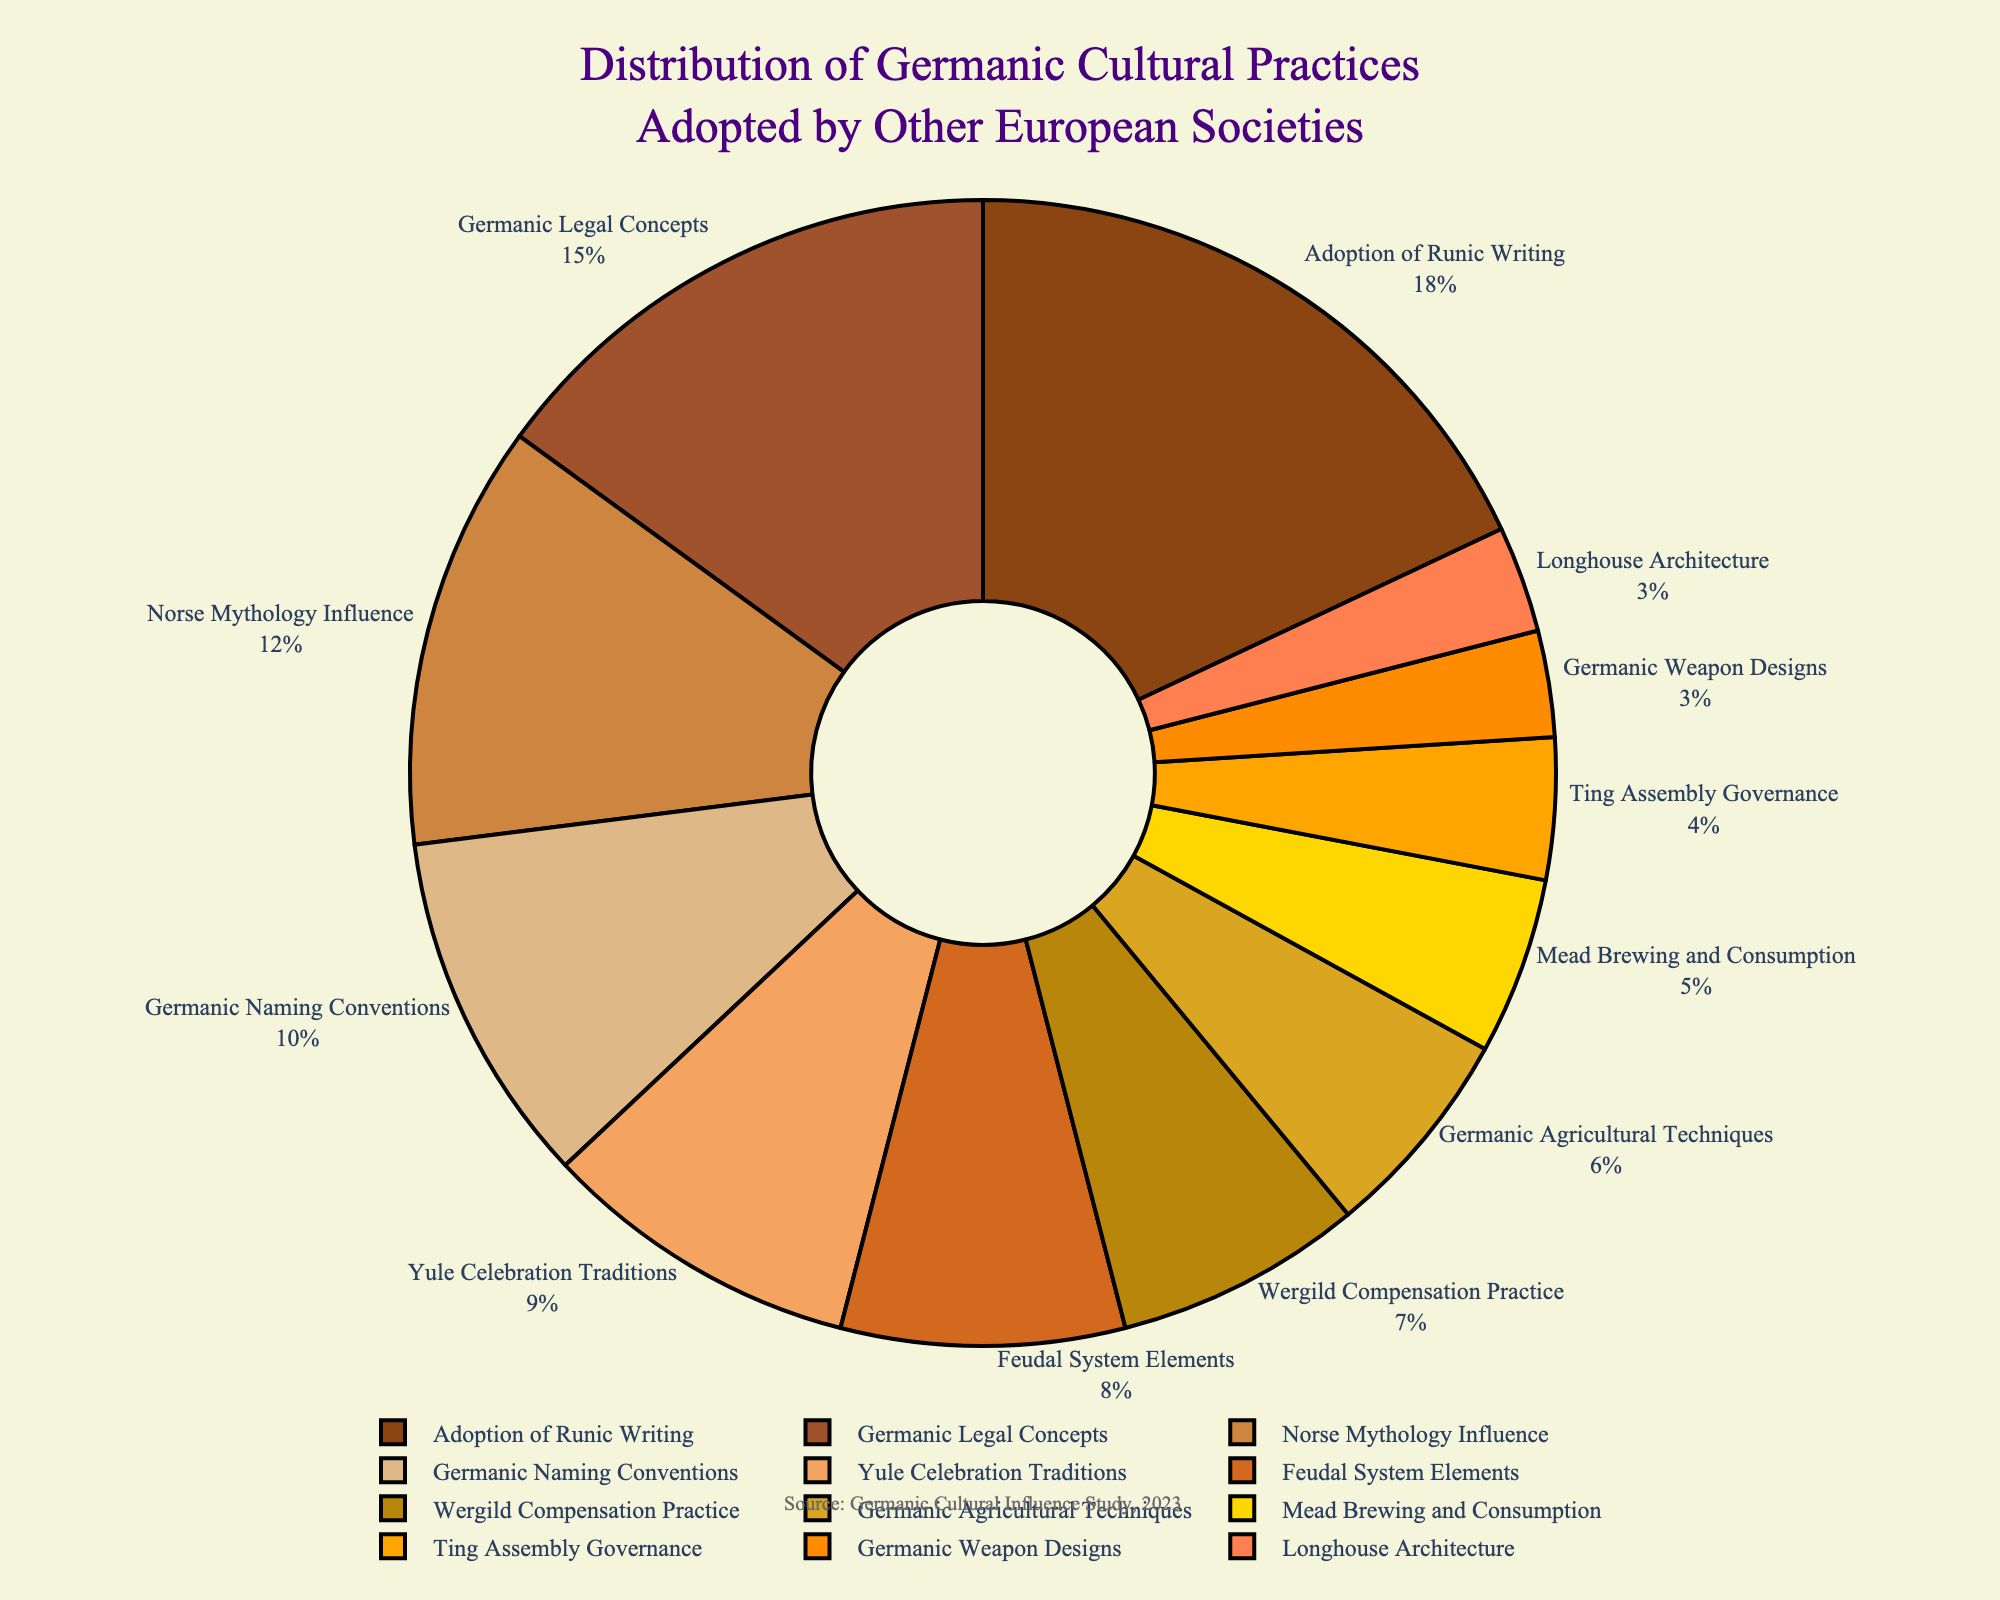Which cultural practice has the highest adoption percentage? The figure shows different cultural practices along with their percentages. The one with the highest percentage indicates the highest adoption.
Answer: Adoption of Runic Writing What is the combined percentage of 'Germanic Legal Concepts' and 'Norse Mythology Influence'? Add the percentages of 'Germanic Legal Concepts' (15%) and 'Norse Mythology Influence' (12%). 15 + 12 = 27%.
Answer: 27% How much more popular is 'Adoption of Runic Writing' compared to 'Longhouse Architecture'? Subtract the percentage of 'Longhouse Architecture' (3%) from 'Adoption of Runic Writing' (18%). 18 - 3 = 15%.
Answer: 15% Which cultural practices are represented with a percentage greater than 10%? Identify and list all cultural practices with percentages greater than 10% from the figure.
Answer: Adoption of Runic Writing, Germanic Legal Concepts, Norse Mythology Influence If 'Yule Celebration Traditions' and 'Germanic Naming Conventions' are combined into a single category, what percentage would this new category represent? Sum the percentages of 'Yule Celebration Traditions' (9%) and 'Germanic Naming Conventions' (10%). 9 + 10 = 19%.
Answer: 19% Rank the top three cultural practices based on their adoption percentages. Identify and list the top three cultural practices in descending order of their percentages.
Answer: 1. Adoption of Runic Writing, 2. Germanic Legal Concepts, 3. Norse Mythology Influence What percentage of Germanic cultural practices is associated with legal concepts including 'Wergild Compensation Practice' and 'Germanic Legal Concepts'? Sum the percentages of 'Wergild Compensation Practice' (7%) and 'Germanic Legal Concepts' (15%). 7 + 15 = 22%.
Answer: 22% What is the least adopted cultural practice? The cultural practice with the smallest percentage is the least adopted one.
Answer: Longhouse Architecture and Germanic Weapon Designs (both 3%) Is 'Mead Brewing and Consumption' adopted more than 'Ting Assembly Governance'? By how much? Compare the percentages: 'Mead Brewing and Consumption' (5%) and 'Ting Assembly Governance' (4%). 5 - 4 = 1%.
Answer: Yes, by 1% What is the total percentage of the top five most adopted cultural practices? Sum the percentages of the top five practices: 18% (Adoption of Runic Writing), 15% (Germanic Legal Concepts), 12% (Norse Mythology Influence), 10% (Germanic Naming Conventions), 9% (Yule Celebration Traditions). 18 + 15 + 12 + 10 + 9 = 64%.
Answer: 64% 